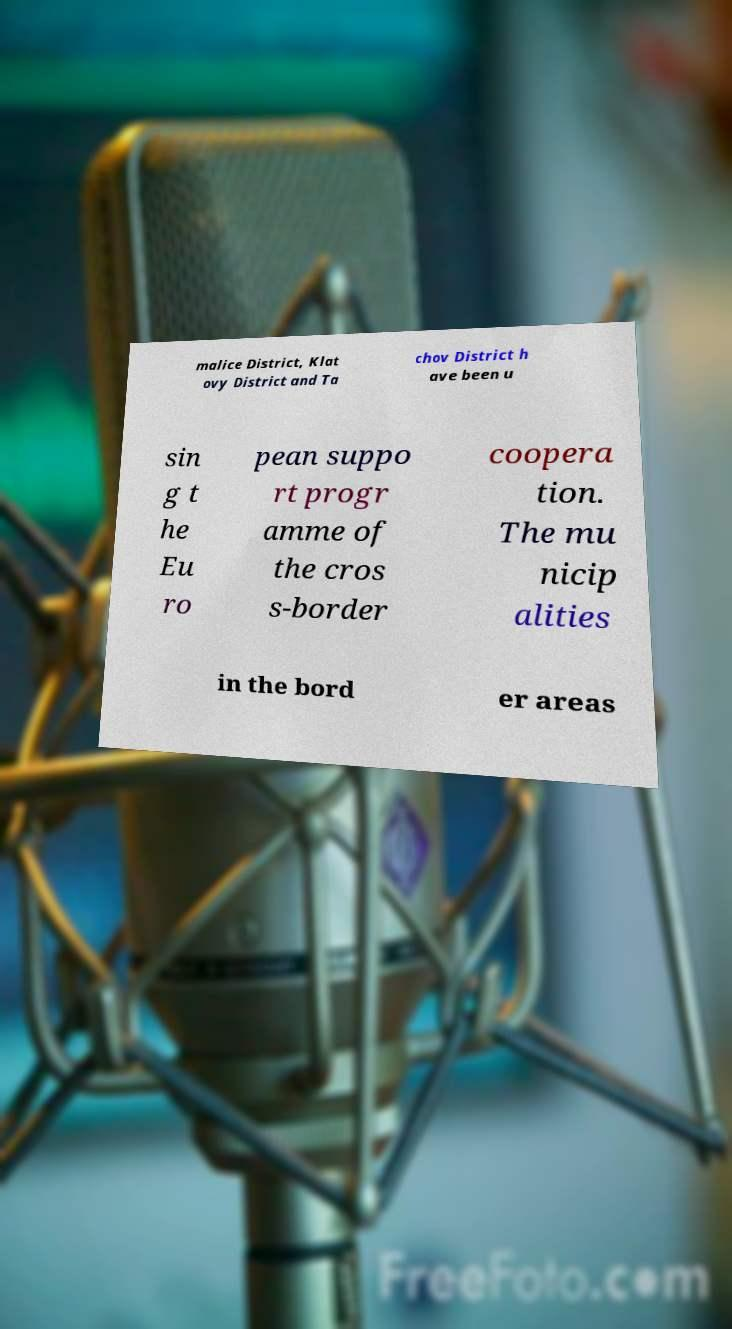What messages or text are displayed in this image? I need them in a readable, typed format. malice District, Klat ovy District and Ta chov District h ave been u sin g t he Eu ro pean suppo rt progr amme of the cros s-border coopera tion. The mu nicip alities in the bord er areas 